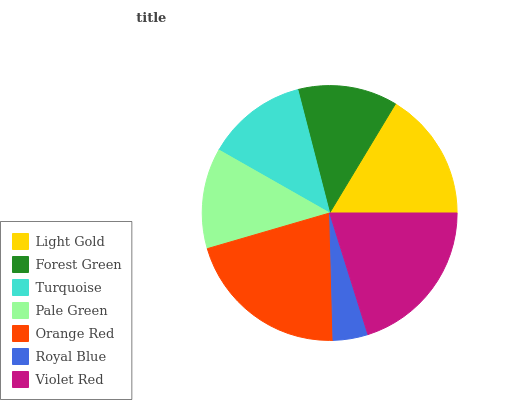Is Royal Blue the minimum?
Answer yes or no. Yes. Is Orange Red the maximum?
Answer yes or no. Yes. Is Forest Green the minimum?
Answer yes or no. No. Is Forest Green the maximum?
Answer yes or no. No. Is Light Gold greater than Forest Green?
Answer yes or no. Yes. Is Forest Green less than Light Gold?
Answer yes or no. Yes. Is Forest Green greater than Light Gold?
Answer yes or no. No. Is Light Gold less than Forest Green?
Answer yes or no. No. Is Turquoise the high median?
Answer yes or no. Yes. Is Turquoise the low median?
Answer yes or no. Yes. Is Pale Green the high median?
Answer yes or no. No. Is Forest Green the low median?
Answer yes or no. No. 